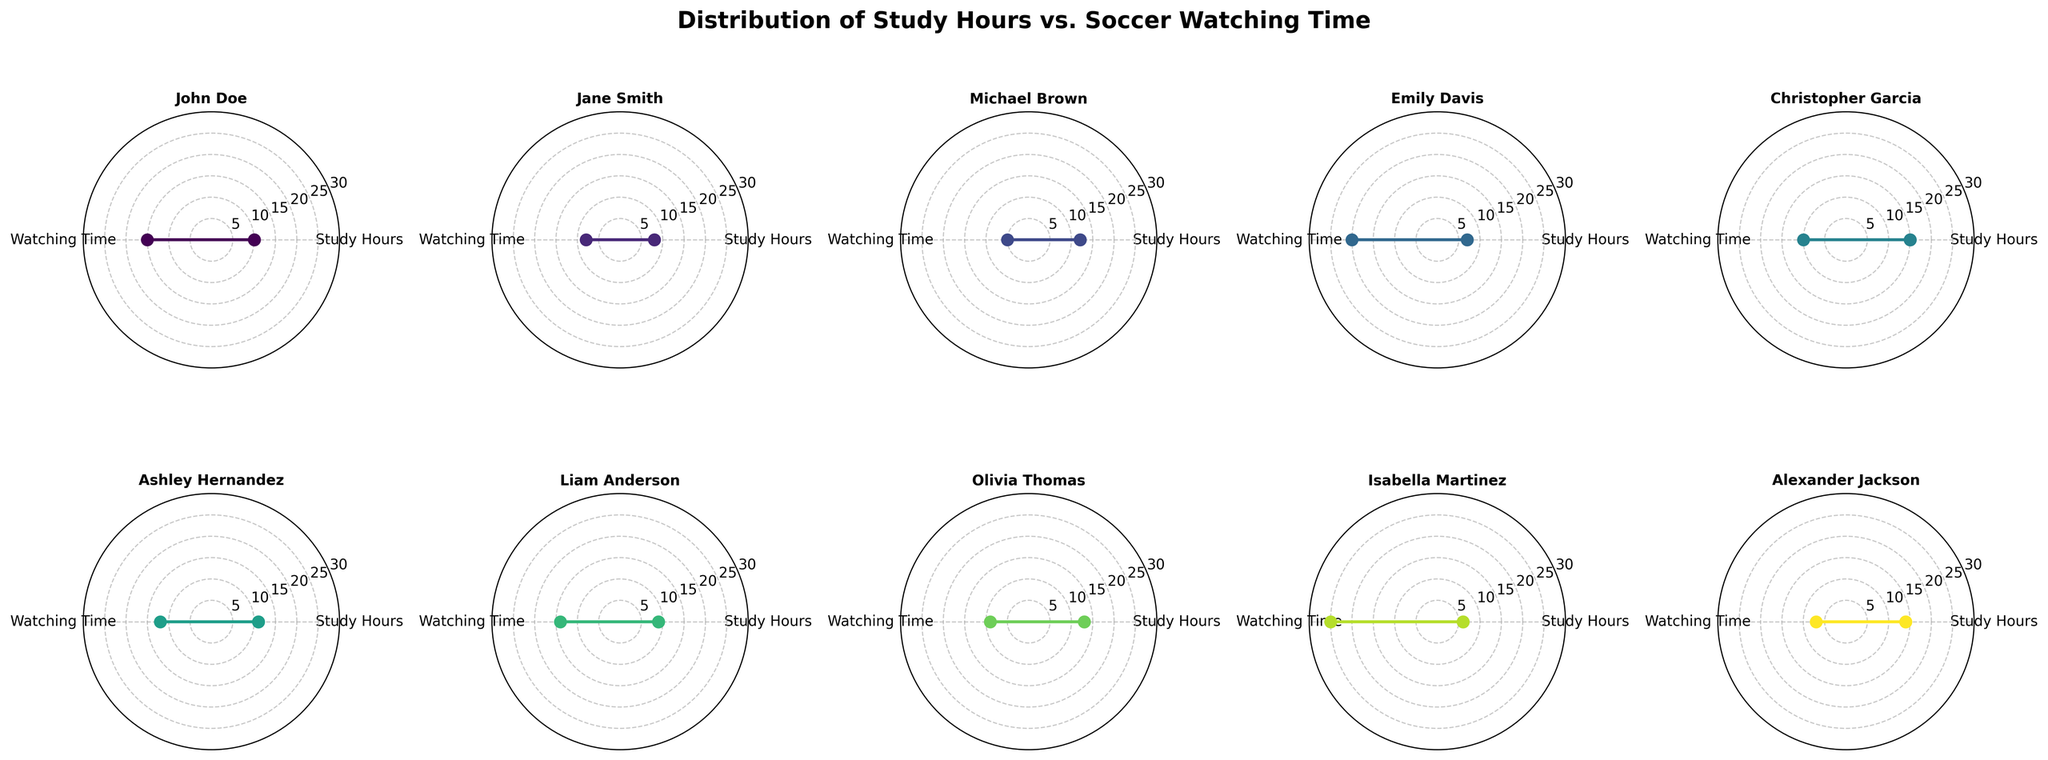Who has the highest soccer watching time? Look at the axis values labeled "Watching Time" for each subplot. Emily Davis has the highest value of 20.
Answer: Emily Davis Which student has the highest study hours? Refer to the axis values labeled "Study Hours" for each subplot. Christopher Garcia has the highest value of 15.
Answer: Christopher Garcia What is the relationship between study hours and watching time for Olivia Thomas? Check Olivia Thomas's subplot. She has 13 study hours and 9 watching hours, forming a close-but-separated radar plot.
Answer: 13 study hours, 9 watching time Compare the study hours and watching time for Isabella Martinez and Michael Brown. Who spends more time studying? Refer to the subplots for Isabella Martinez and Michael Brown. Isabella has 6 study hours, and Michael has 12 study hours. Michael studies more.
Answer: Michael Brown Which student has approximately equal study hours and soccer watching time? Look for subplots where the two axes' values are close. Jane Smith has 8 study hours and 8 watching hours.
Answer: Jane Smith What is the median watching time among all students? List the watching times: 5, 7, 8, 9, 10, 12, 14, 15, 20, 25. The middle values are 10 and 12, so the median is (10+12)/2.
Answer: 11.0 Which students have watching times greater than their study hours? Compare both values in each subplot: Emily Davis, Liam Anderson, John Doe, Ashley Hernandez, and Isabella Martinez have higher watching times.
Answer: Multiple names (Emily Davis, Liam Anderson, John Doe, Ashley Hernandez, Isabella Martinez) What is the total sum of study hours for all students? Add the study hours for all students: 10 + 8 + 12 + 7 + 15 + 11 + 9 + 13 + 6 + 14 = 105.
Answer: 105 Identify the axis labels on the radar charts. Notice the two repeated grid labels for each subplot. They are 'Study Hours' and 'Watching Time'.
Answer: Study Hours, Watching Time How does Alexander Jackson's radar plot compare in shape to Ashley Hernandez's? Alexander has 14 study hours and 7 watching hours (tall and narrow shape). Ashley has 11 study hours and 12 watching hours (more balanced). Their shapes differ significantly.
Answer: Different shapes, Alexander's is tall and narrow, Ashley's is more balanced 